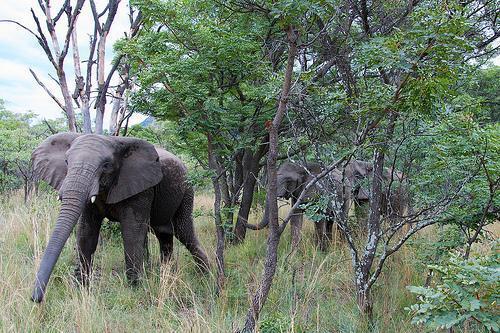How many elephants are there?
Give a very brief answer. 3. How many elephants have visible tusks?
Give a very brief answer. 1. 